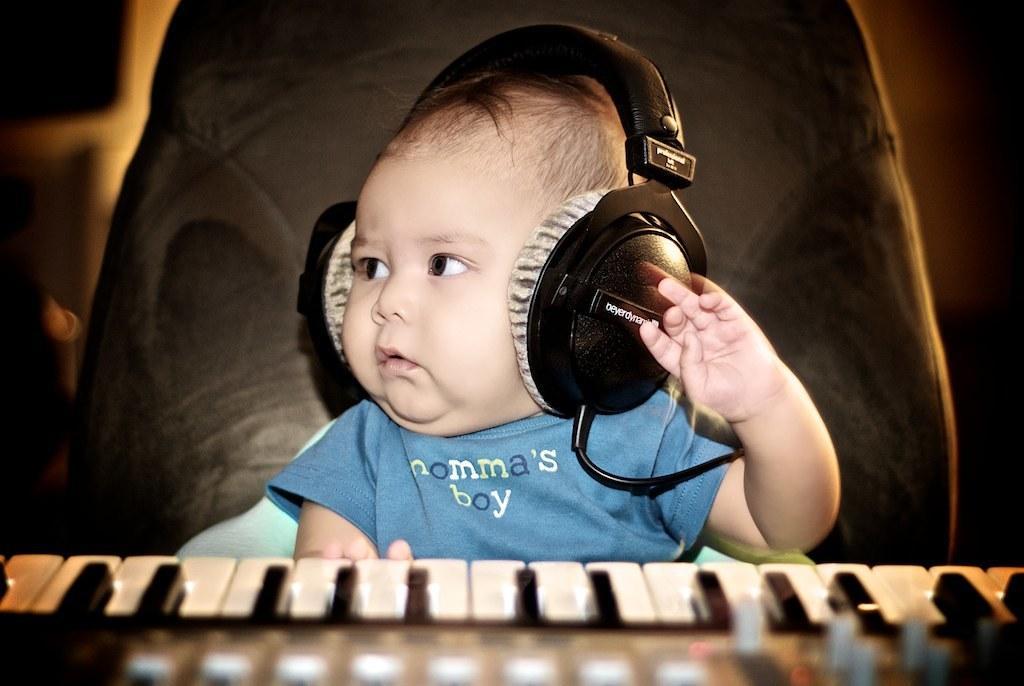Please provide a concise description of this image. A little boy is wearing headphones. He is wearing a blue T shirt with a label mama's boy. He sat in front of keyboard. He is looking at a side and raising his hand. 